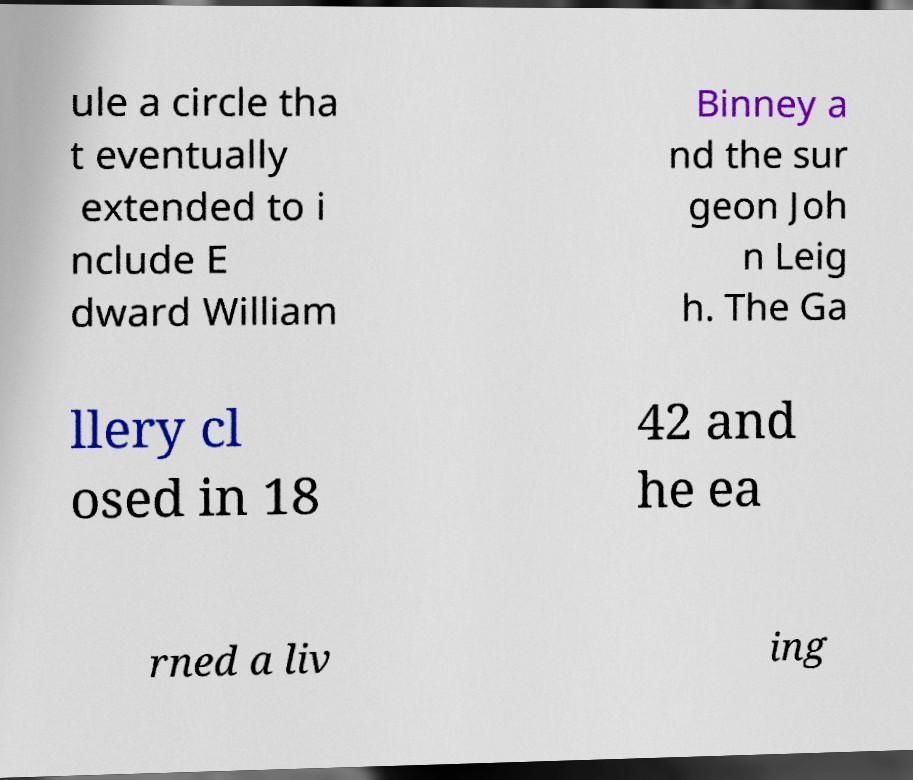Can you accurately transcribe the text from the provided image for me? ule a circle tha t eventually extended to i nclude E dward William Binney a nd the sur geon Joh n Leig h. The Ga llery cl osed in 18 42 and he ea rned a liv ing 